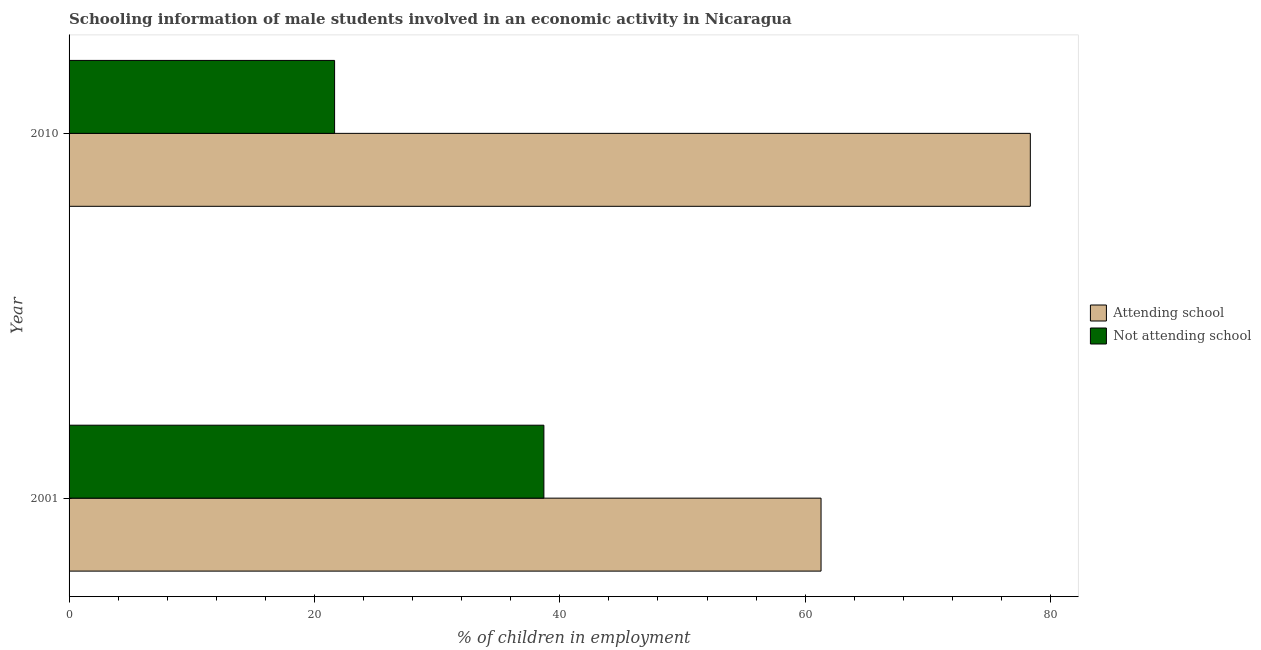How many different coloured bars are there?
Your answer should be very brief. 2. How many groups of bars are there?
Your response must be concise. 2. Are the number of bars per tick equal to the number of legend labels?
Ensure brevity in your answer.  Yes. Are the number of bars on each tick of the Y-axis equal?
Provide a succinct answer. Yes. How many bars are there on the 2nd tick from the top?
Give a very brief answer. 2. What is the percentage of employed males who are attending school in 2001?
Your answer should be very brief. 61.3. Across all years, what is the maximum percentage of employed males who are attending school?
Offer a terse response. 78.36. Across all years, what is the minimum percentage of employed males who are attending school?
Your answer should be very brief. 61.3. In which year was the percentage of employed males who are attending school maximum?
Keep it short and to the point. 2010. In which year was the percentage of employed males who are attending school minimum?
Offer a terse response. 2001. What is the total percentage of employed males who are attending school in the graph?
Ensure brevity in your answer.  139.65. What is the difference between the percentage of employed males who are attending school in 2001 and that in 2010?
Your answer should be very brief. -17.06. What is the difference between the percentage of employed males who are attending school in 2010 and the percentage of employed males who are not attending school in 2001?
Your response must be concise. 39.65. What is the average percentage of employed males who are not attending school per year?
Ensure brevity in your answer.  30.17. In the year 2010, what is the difference between the percentage of employed males who are attending school and percentage of employed males who are not attending school?
Ensure brevity in your answer.  56.71. In how many years, is the percentage of employed males who are not attending school greater than 68 %?
Give a very brief answer. 0. What is the ratio of the percentage of employed males who are attending school in 2001 to that in 2010?
Give a very brief answer. 0.78. In how many years, is the percentage of employed males who are not attending school greater than the average percentage of employed males who are not attending school taken over all years?
Give a very brief answer. 1. What does the 2nd bar from the top in 2001 represents?
Provide a succinct answer. Attending school. What does the 1st bar from the bottom in 2001 represents?
Give a very brief answer. Attending school. Are all the bars in the graph horizontal?
Offer a terse response. Yes. Does the graph contain any zero values?
Ensure brevity in your answer.  No. Where does the legend appear in the graph?
Ensure brevity in your answer.  Center right. How many legend labels are there?
Offer a terse response. 2. How are the legend labels stacked?
Offer a very short reply. Vertical. What is the title of the graph?
Keep it short and to the point. Schooling information of male students involved in an economic activity in Nicaragua. Does "Study and work" appear as one of the legend labels in the graph?
Offer a terse response. No. What is the label or title of the X-axis?
Your response must be concise. % of children in employment. What is the % of children in employment in Attending school in 2001?
Your answer should be compact. 61.3. What is the % of children in employment of Not attending school in 2001?
Keep it short and to the point. 38.7. What is the % of children in employment of Attending school in 2010?
Your response must be concise. 78.36. What is the % of children in employment of Not attending school in 2010?
Your answer should be compact. 21.64. Across all years, what is the maximum % of children in employment in Attending school?
Keep it short and to the point. 78.36. Across all years, what is the maximum % of children in employment in Not attending school?
Your answer should be very brief. 38.7. Across all years, what is the minimum % of children in employment in Attending school?
Make the answer very short. 61.3. Across all years, what is the minimum % of children in employment of Not attending school?
Make the answer very short. 21.64. What is the total % of children in employment of Attending school in the graph?
Your response must be concise. 139.65. What is the total % of children in employment of Not attending school in the graph?
Your response must be concise. 60.35. What is the difference between the % of children in employment in Attending school in 2001 and that in 2010?
Your response must be concise. -17.06. What is the difference between the % of children in employment of Not attending school in 2001 and that in 2010?
Offer a terse response. 17.06. What is the difference between the % of children in employment in Attending school in 2001 and the % of children in employment in Not attending school in 2010?
Provide a short and direct response. 39.65. What is the average % of children in employment in Attending school per year?
Provide a succinct answer. 69.83. What is the average % of children in employment of Not attending school per year?
Keep it short and to the point. 30.17. In the year 2001, what is the difference between the % of children in employment of Attending school and % of children in employment of Not attending school?
Offer a very short reply. 22.59. In the year 2010, what is the difference between the % of children in employment of Attending school and % of children in employment of Not attending school?
Offer a very short reply. 56.71. What is the ratio of the % of children in employment of Attending school in 2001 to that in 2010?
Offer a terse response. 0.78. What is the ratio of the % of children in employment of Not attending school in 2001 to that in 2010?
Ensure brevity in your answer.  1.79. What is the difference between the highest and the second highest % of children in employment of Attending school?
Your response must be concise. 17.06. What is the difference between the highest and the second highest % of children in employment in Not attending school?
Keep it short and to the point. 17.06. What is the difference between the highest and the lowest % of children in employment of Attending school?
Make the answer very short. 17.06. What is the difference between the highest and the lowest % of children in employment of Not attending school?
Keep it short and to the point. 17.06. 